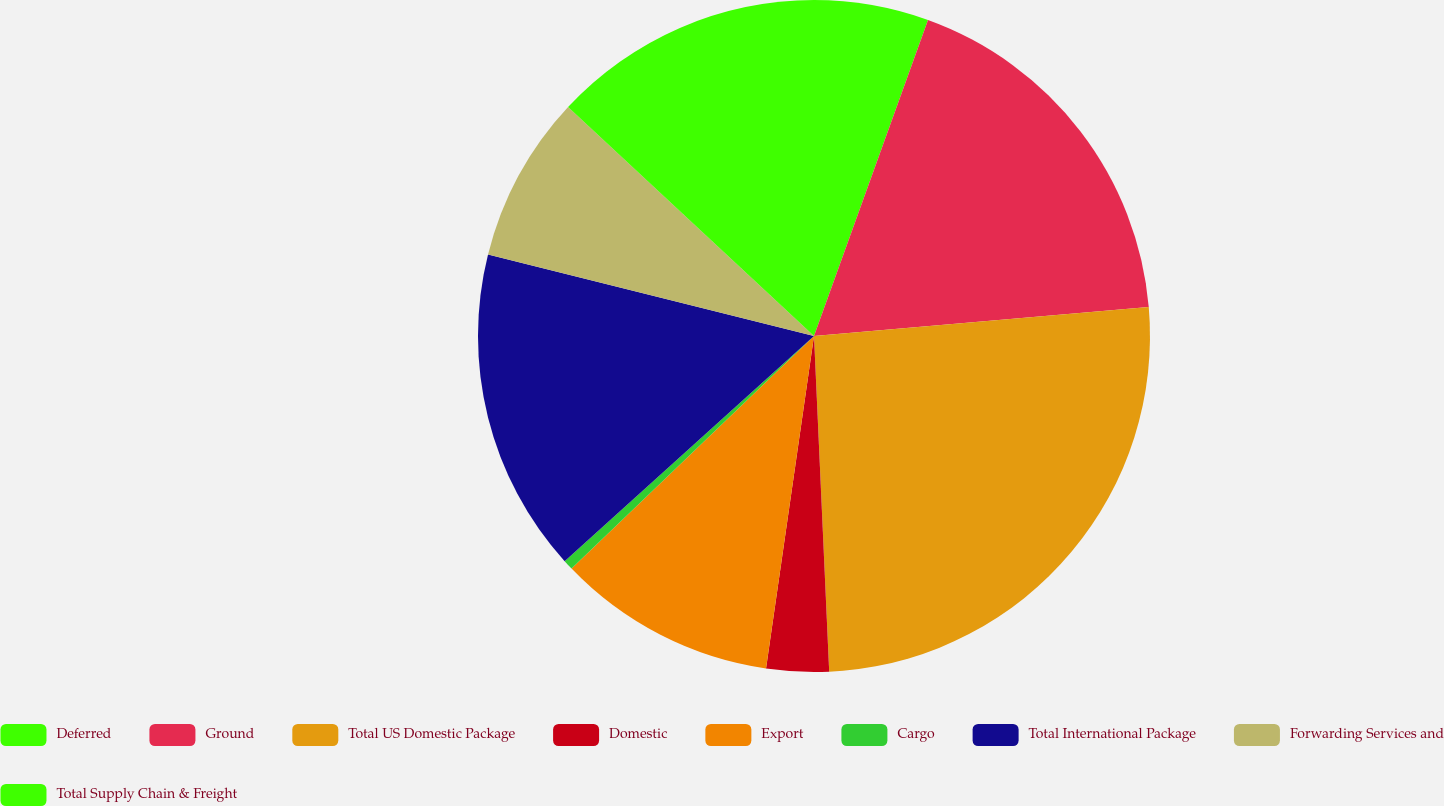Convert chart. <chart><loc_0><loc_0><loc_500><loc_500><pie_chart><fcel>Deferred<fcel>Ground<fcel>Total US Domestic Package<fcel>Domestic<fcel>Export<fcel>Cargo<fcel>Total International Package<fcel>Forwarding Services and<fcel>Total Supply Chain & Freight<nl><fcel>5.51%<fcel>18.11%<fcel>25.66%<fcel>3.0%<fcel>10.55%<fcel>0.48%<fcel>15.59%<fcel>8.03%<fcel>13.07%<nl></chart> 